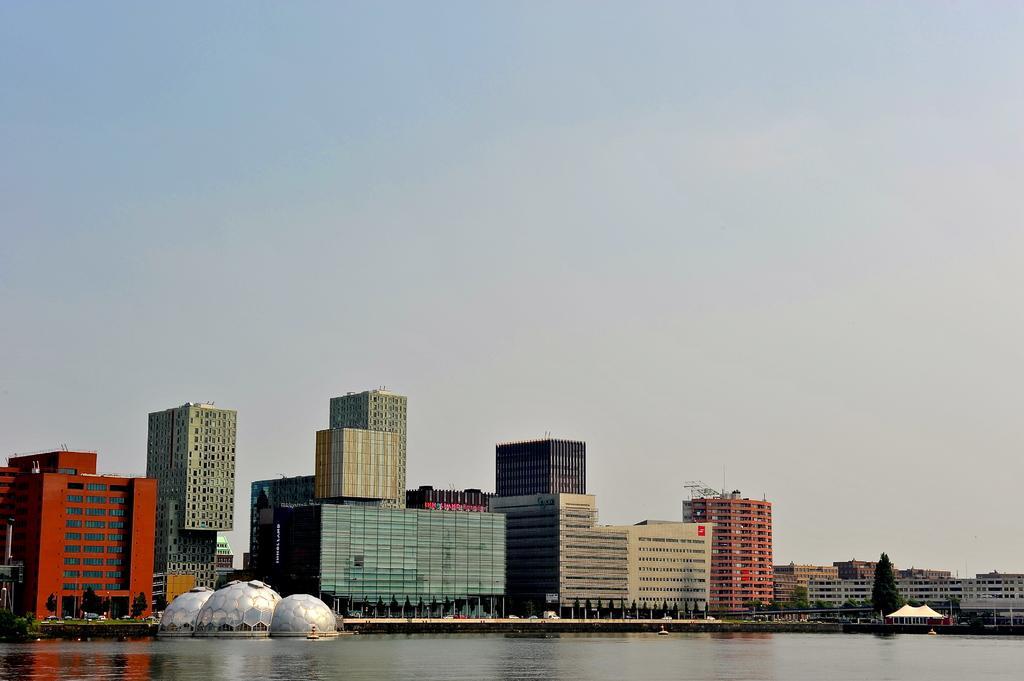Can you describe this image briefly? In the foreground of the picture there is water. In the center of the picture there are buildings, trees and vehicles. Sky is sunny. 